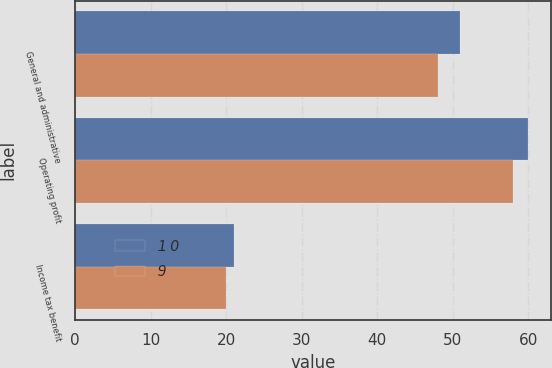<chart> <loc_0><loc_0><loc_500><loc_500><stacked_bar_chart><ecel><fcel>General and administrative<fcel>Operating profit<fcel>Income tax benefit<nl><fcel>1 0<fcel>51<fcel>60<fcel>21<nl><fcel>9<fcel>48<fcel>58<fcel>20<nl></chart> 